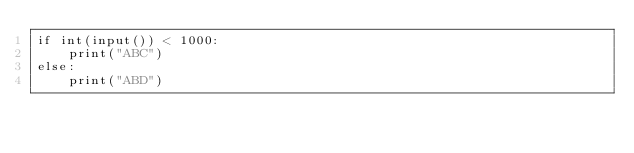<code> <loc_0><loc_0><loc_500><loc_500><_Python_>if int(input()) < 1000:
    print("ABC")
else:
    print("ABD")
</code> 